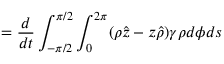Convert formula to latex. <formula><loc_0><loc_0><loc_500><loc_500>= \frac { d } { d t } \int _ { - \pi / 2 } ^ { \pi / 2 } \int _ { 0 } ^ { 2 \pi } ( \rho \hat { z } - z \hat { \rho } ) \gamma \rho d \phi d s</formula> 